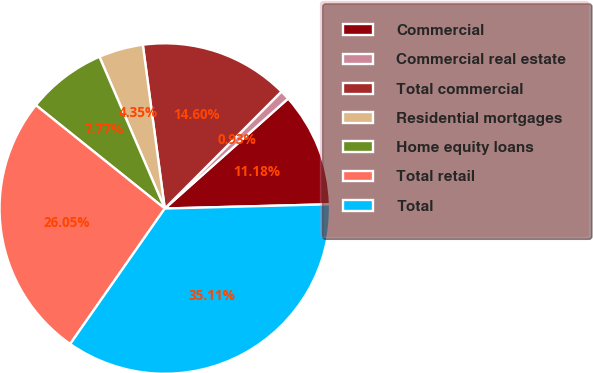Convert chart to OTSL. <chart><loc_0><loc_0><loc_500><loc_500><pie_chart><fcel>Commercial<fcel>Commercial real estate<fcel>Total commercial<fcel>Residential mortgages<fcel>Home equity loans<fcel>Total retail<fcel>Total<nl><fcel>11.18%<fcel>0.93%<fcel>14.6%<fcel>4.35%<fcel>7.77%<fcel>26.05%<fcel>35.11%<nl></chart> 